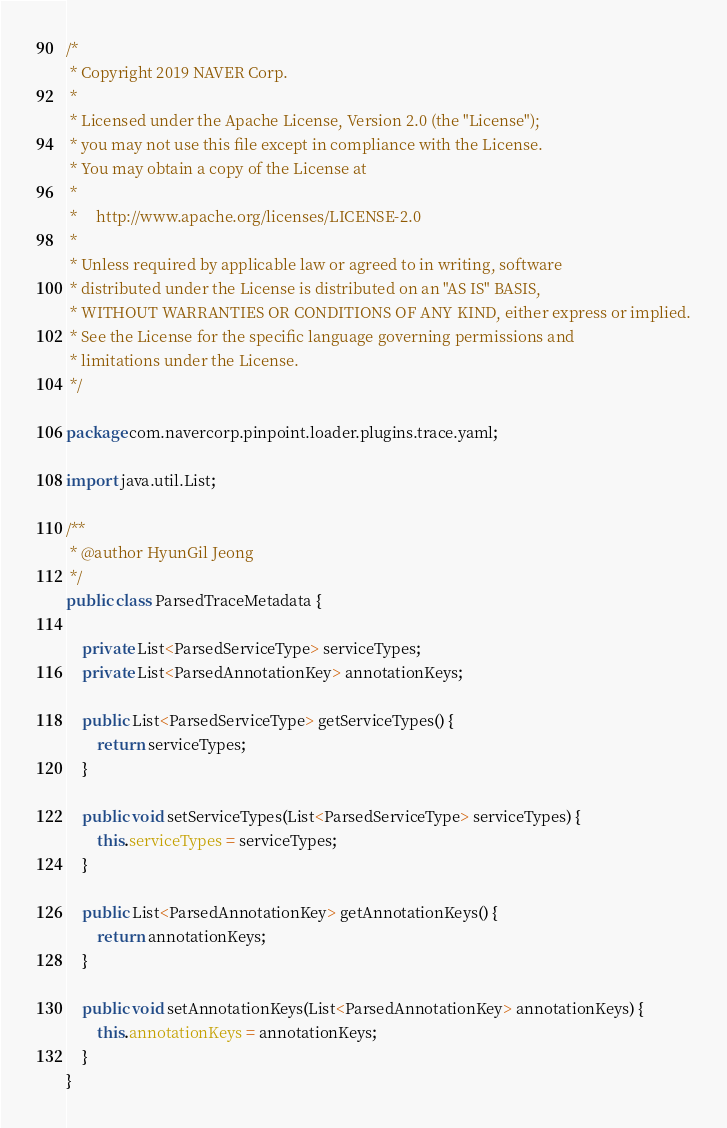Convert code to text. <code><loc_0><loc_0><loc_500><loc_500><_Java_>/*
 * Copyright 2019 NAVER Corp.
 *
 * Licensed under the Apache License, Version 2.0 (the "License");
 * you may not use this file except in compliance with the License.
 * You may obtain a copy of the License at
 *
 *     http://www.apache.org/licenses/LICENSE-2.0
 *
 * Unless required by applicable law or agreed to in writing, software
 * distributed under the License is distributed on an "AS IS" BASIS,
 * WITHOUT WARRANTIES OR CONDITIONS OF ANY KIND, either express or implied.
 * See the License for the specific language governing permissions and
 * limitations under the License.
 */

package com.navercorp.pinpoint.loader.plugins.trace.yaml;

import java.util.List;

/**
 * @author HyunGil Jeong
 */
public class ParsedTraceMetadata {

    private List<ParsedServiceType> serviceTypes;
    private List<ParsedAnnotationKey> annotationKeys;

    public List<ParsedServiceType> getServiceTypes() {
        return serviceTypes;
    }

    public void setServiceTypes(List<ParsedServiceType> serviceTypes) {
        this.serviceTypes = serviceTypes;
    }

    public List<ParsedAnnotationKey> getAnnotationKeys() {
        return annotationKeys;
    }

    public void setAnnotationKeys(List<ParsedAnnotationKey> annotationKeys) {
        this.annotationKeys = annotationKeys;
    }
}
</code> 